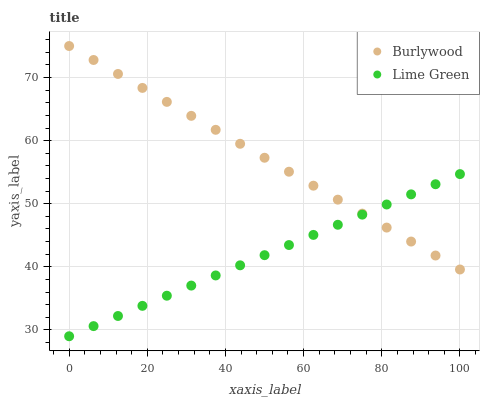Does Lime Green have the minimum area under the curve?
Answer yes or no. Yes. Does Burlywood have the maximum area under the curve?
Answer yes or no. Yes. Does Lime Green have the maximum area under the curve?
Answer yes or no. No. Is Burlywood the smoothest?
Answer yes or no. Yes. Is Lime Green the roughest?
Answer yes or no. Yes. Is Lime Green the smoothest?
Answer yes or no. No. Does Lime Green have the lowest value?
Answer yes or no. Yes. Does Burlywood have the highest value?
Answer yes or no. Yes. Does Lime Green have the highest value?
Answer yes or no. No. Does Lime Green intersect Burlywood?
Answer yes or no. Yes. Is Lime Green less than Burlywood?
Answer yes or no. No. Is Lime Green greater than Burlywood?
Answer yes or no. No. 